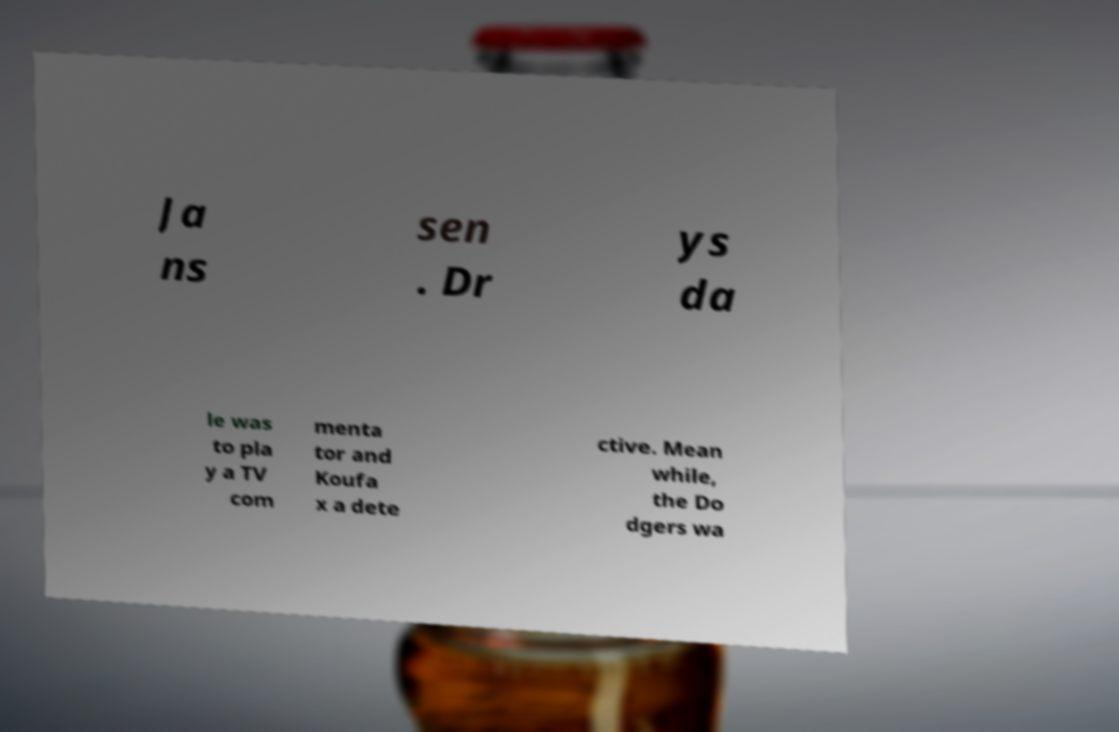There's text embedded in this image that I need extracted. Can you transcribe it verbatim? Ja ns sen . Dr ys da le was to pla y a TV com menta tor and Koufa x a dete ctive. Mean while, the Do dgers wa 